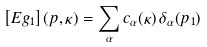<formula> <loc_0><loc_0><loc_500><loc_500>\left [ E g _ { 1 } \right ] ( p , \kappa ) = \sum _ { \alpha } c _ { \alpha } ( \kappa ) \, \delta _ { \alpha } ( p _ { 1 } )</formula> 